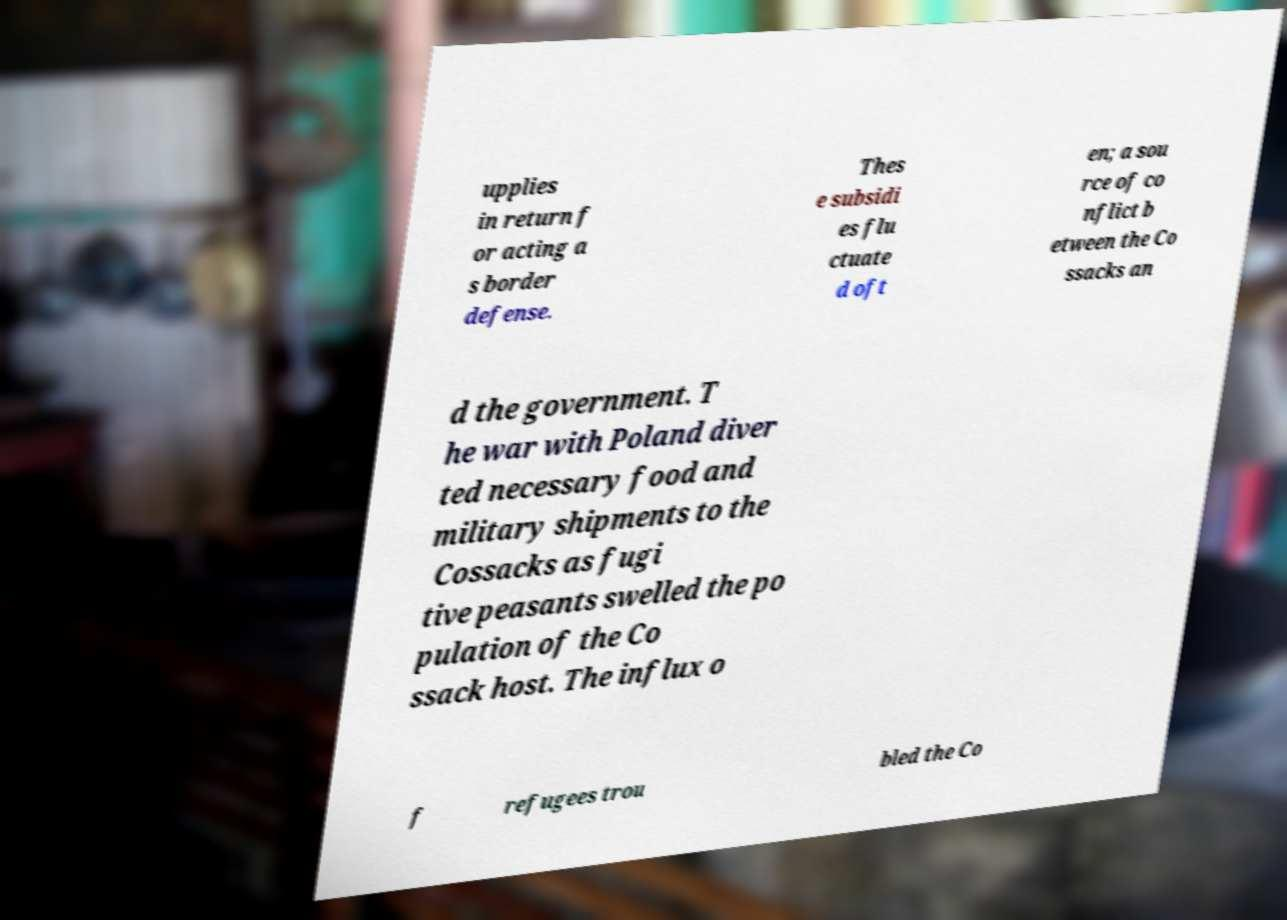Can you accurately transcribe the text from the provided image for me? upplies in return f or acting a s border defense. Thes e subsidi es flu ctuate d oft en; a sou rce of co nflict b etween the Co ssacks an d the government. T he war with Poland diver ted necessary food and military shipments to the Cossacks as fugi tive peasants swelled the po pulation of the Co ssack host. The influx o f refugees trou bled the Co 